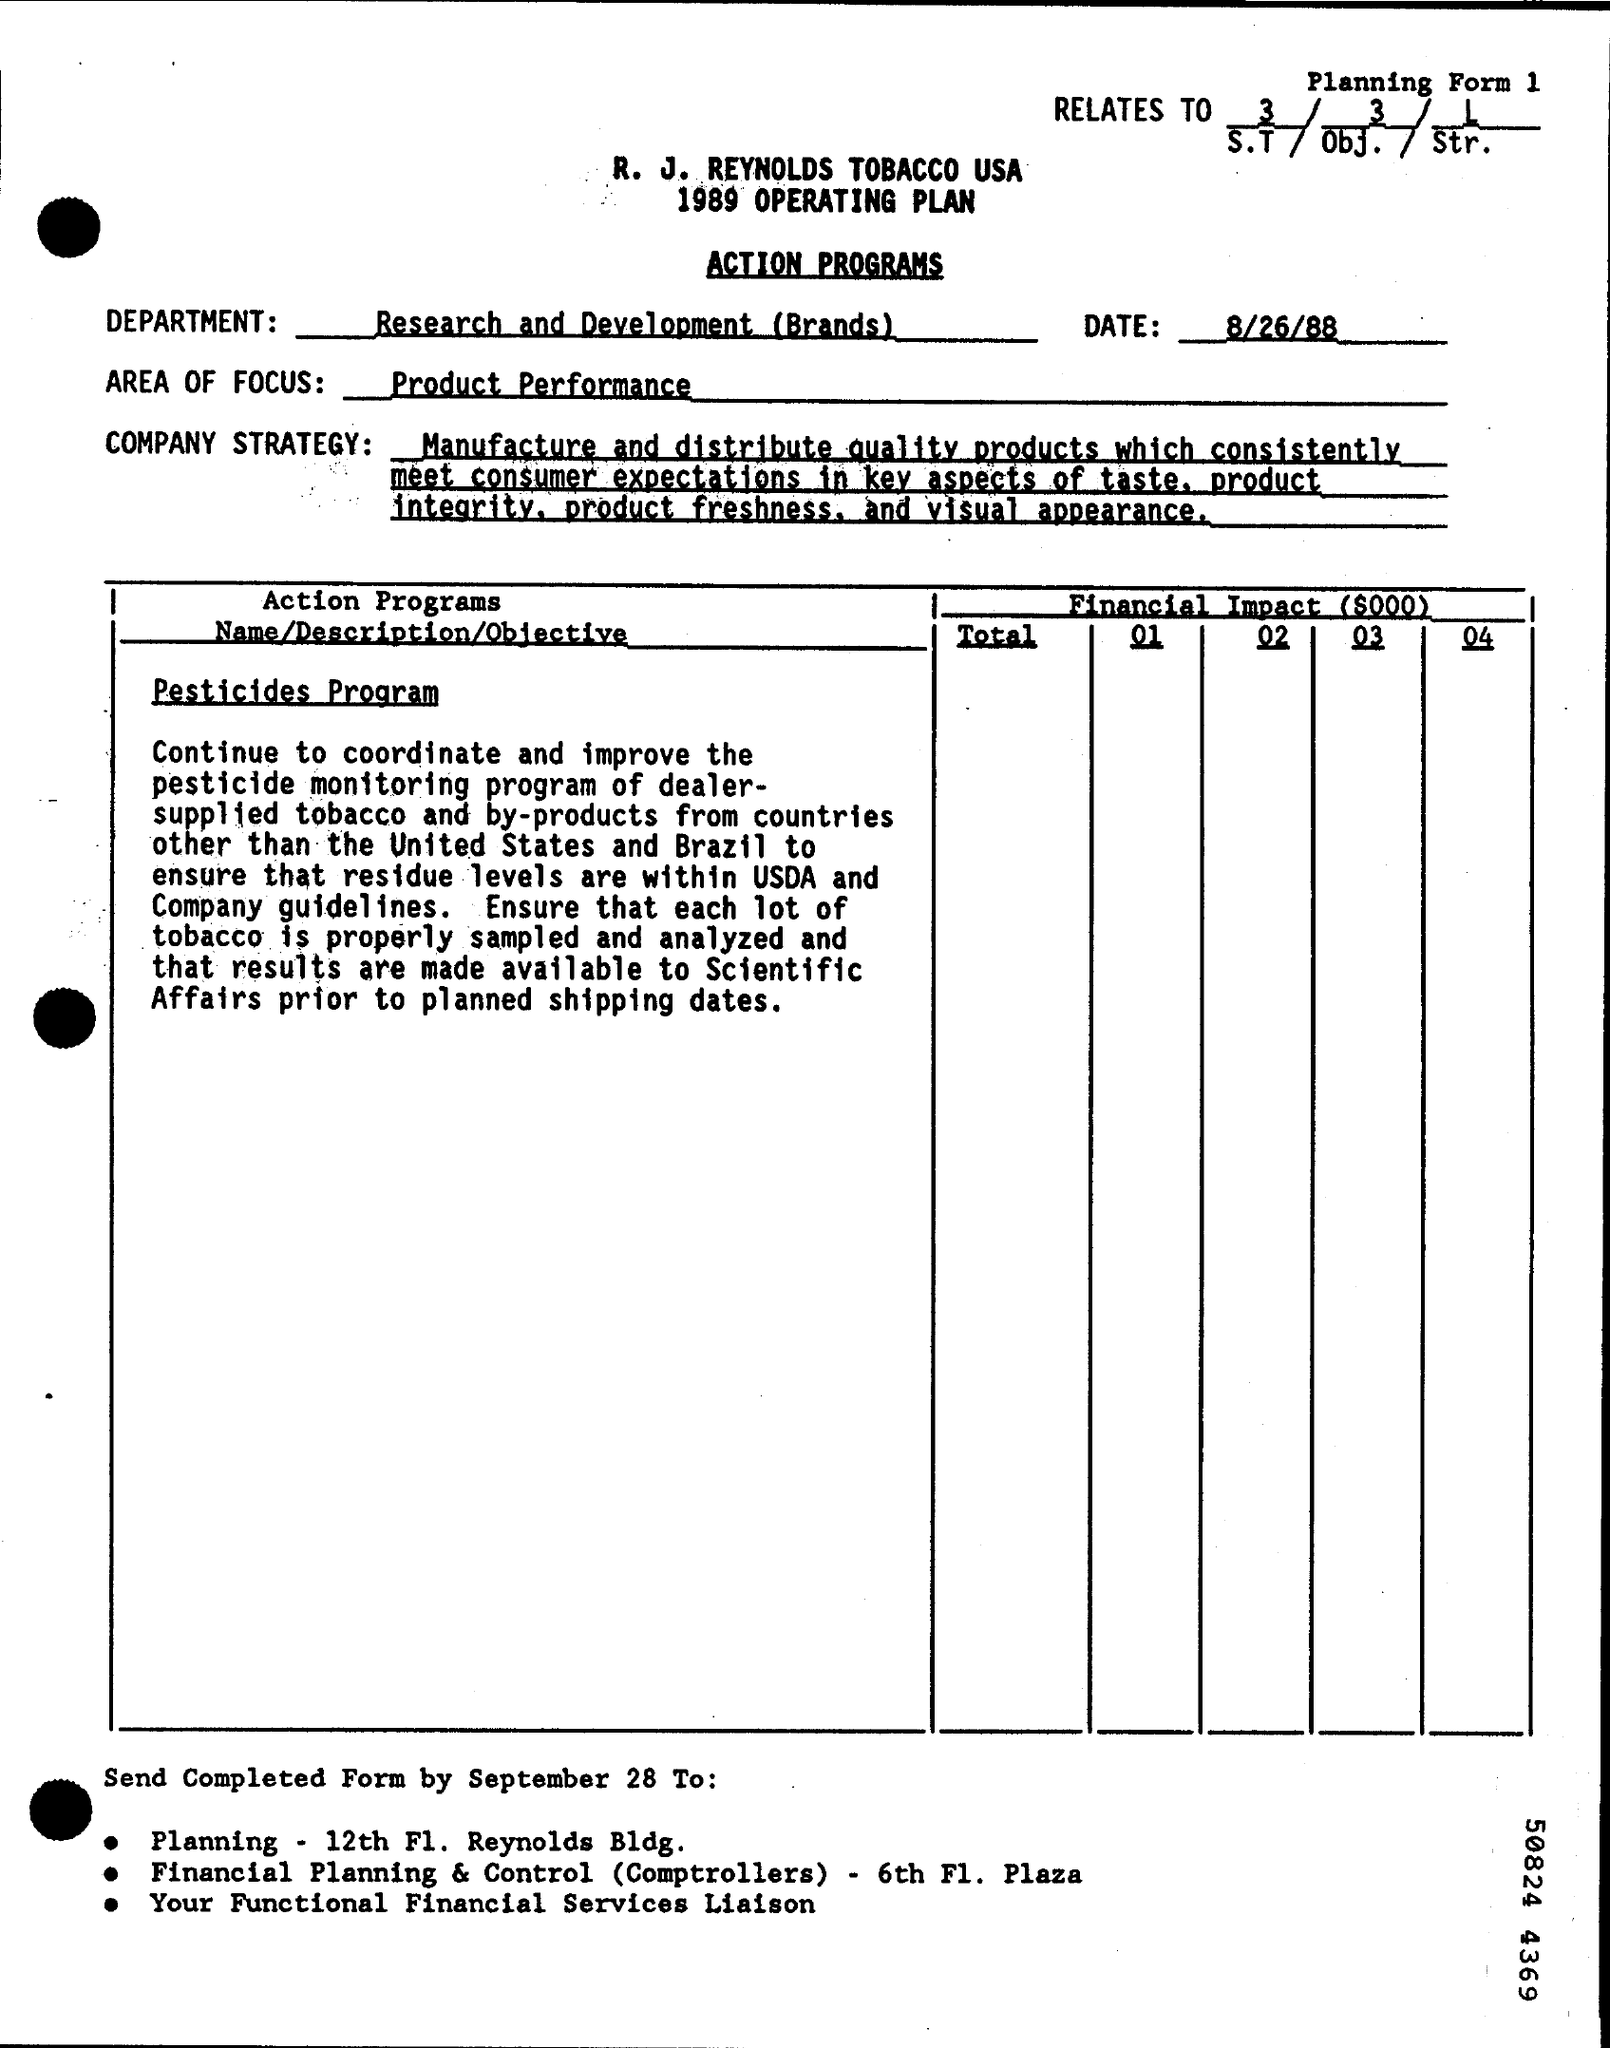Mention a couple of crucial points in this snapshot. The AREA OF FOCUS field contains the text 'product performance,' which describes the focus of the company or product in question. The Department Name is responsible for conducting research and development related to the brand. The Memorandum was dated on August 26, 1988. 